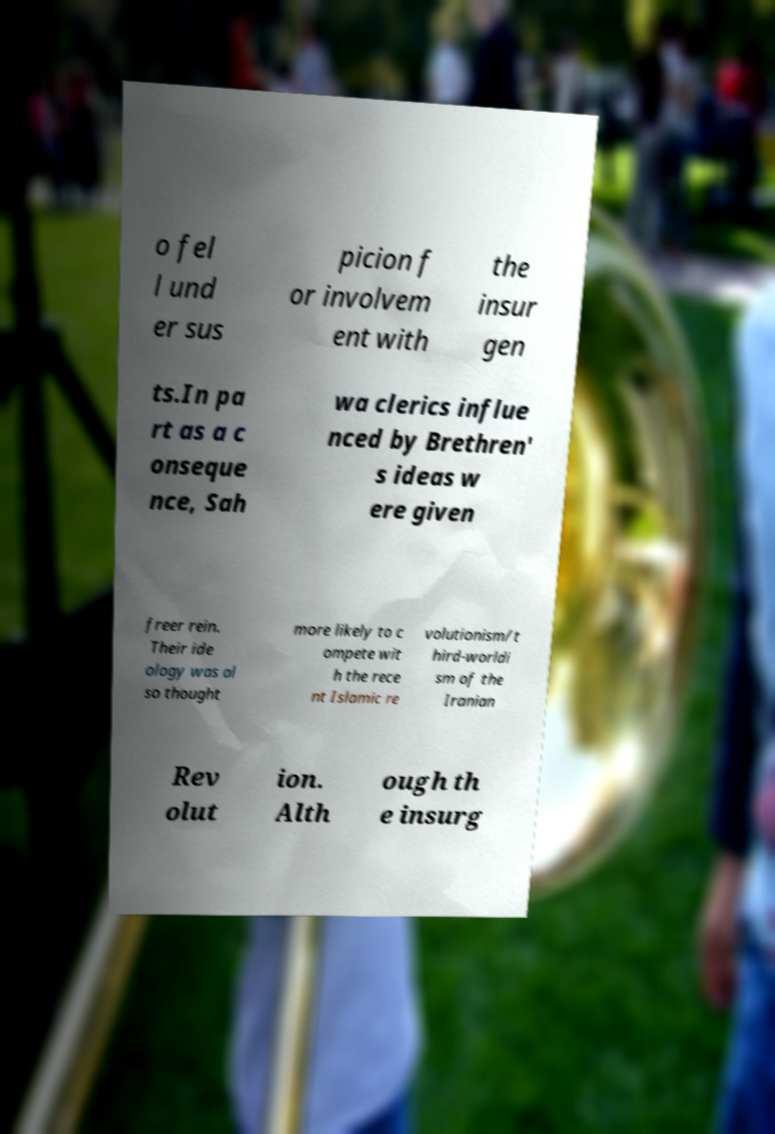What messages or text are displayed in this image? I need them in a readable, typed format. o fel l und er sus picion f or involvem ent with the insur gen ts.In pa rt as a c onseque nce, Sah wa clerics influe nced by Brethren' s ideas w ere given freer rein. Their ide ology was al so thought more likely to c ompete wit h the rece nt Islamic re volutionism/t hird-worldi sm of the Iranian Rev olut ion. Alth ough th e insurg 